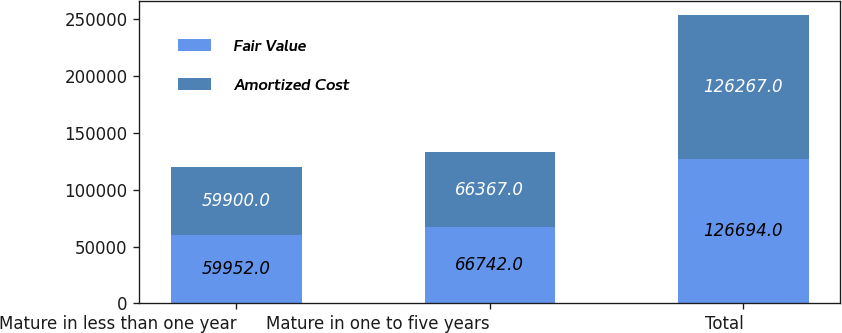Convert chart. <chart><loc_0><loc_0><loc_500><loc_500><stacked_bar_chart><ecel><fcel>Mature in less than one year<fcel>Mature in one to five years<fcel>Total<nl><fcel>Fair Value<fcel>59952<fcel>66742<fcel>126694<nl><fcel>Amortized Cost<fcel>59900<fcel>66367<fcel>126267<nl></chart> 